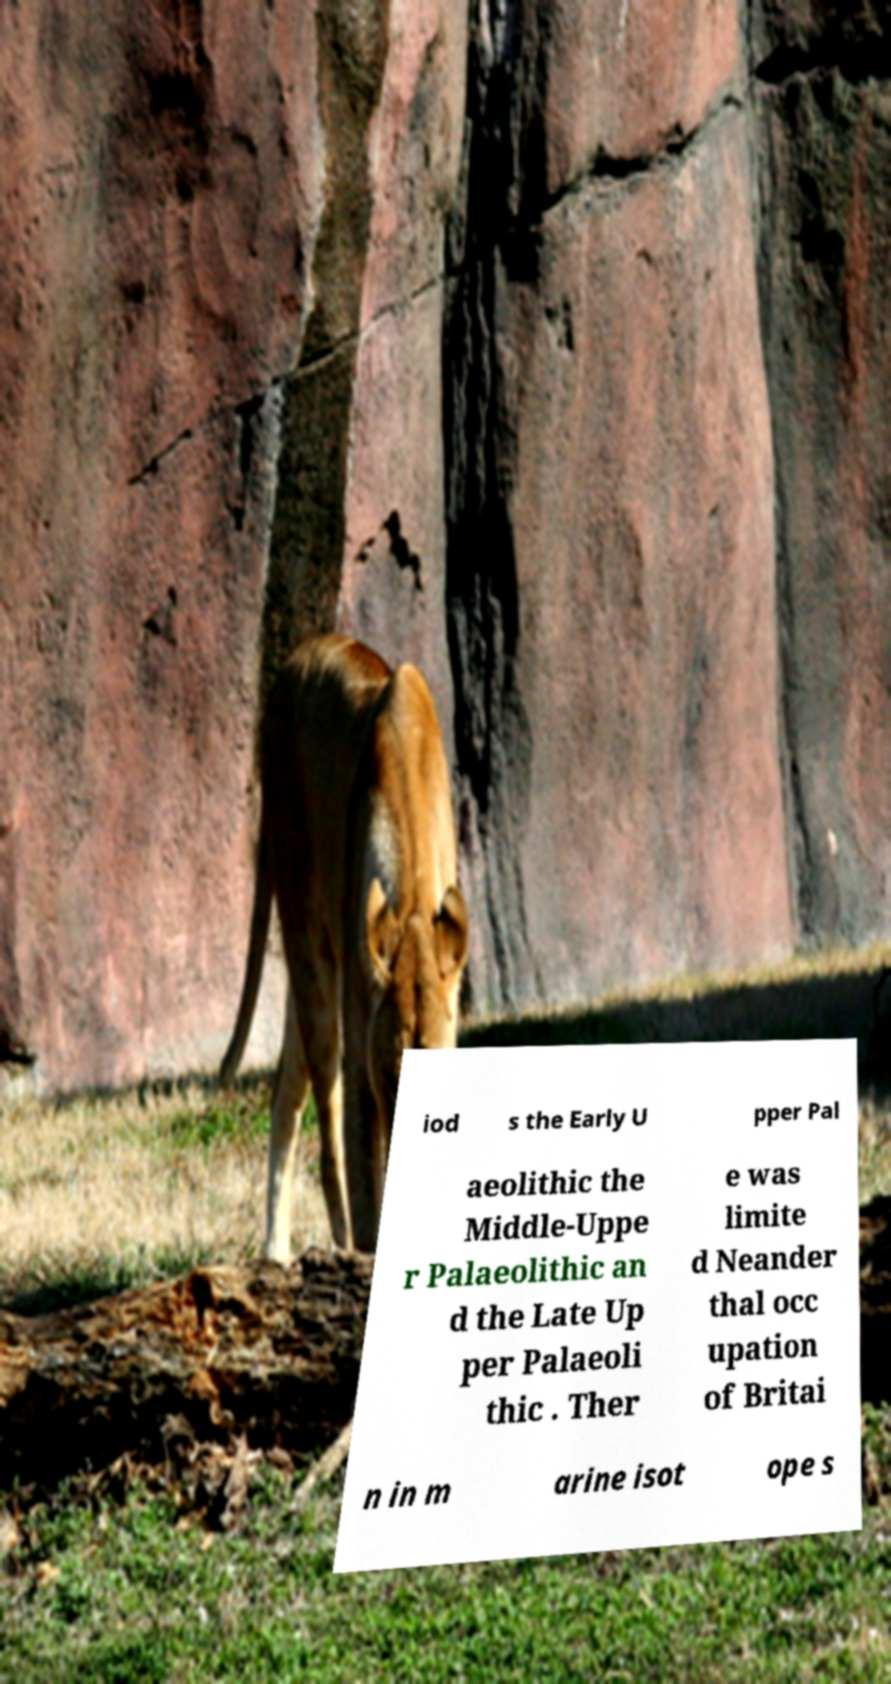Please read and relay the text visible in this image. What does it say? iod s the Early U pper Pal aeolithic the Middle-Uppe r Palaeolithic an d the Late Up per Palaeoli thic . Ther e was limite d Neander thal occ upation of Britai n in m arine isot ope s 